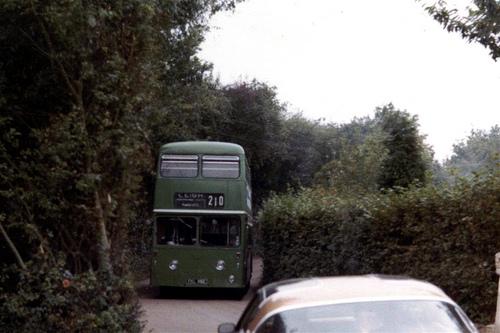How many decks does the bus have?
Answer briefly. 2. Are they on a pavement road?
Write a very short answer. No. What color is the bus?
Write a very short answer. Green. 